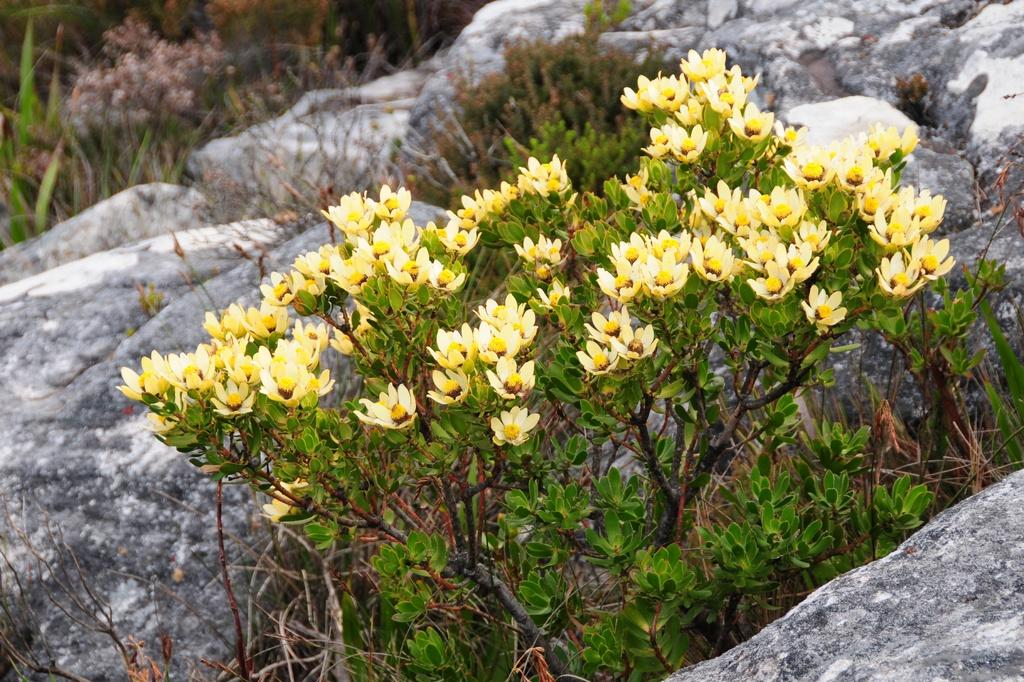What color are the flowers in the image? The flowers in the image are yellow. What color are the plants in the image? The plants in the image are green. What can be seen in the background of the image? There are rocks visible in the background of the image. What type of advertisement is displayed on the leg in the image? There is no leg or advertisement present in the image. 